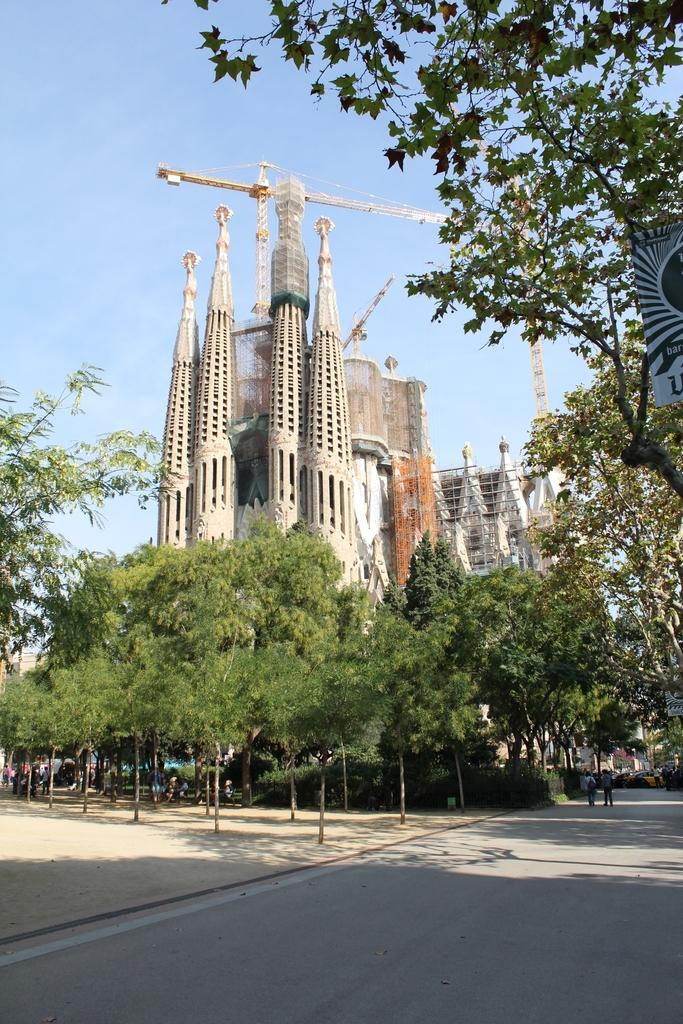What is the main subject of the image? There is a big building under construction in the image. What machinery can be seen at the construction site? A huge crane is present at the construction site. What natural elements are visible around the building? There are a lot of trees around the building. What color is the thumb of the person operating the crane in the image? There is no person operating the crane visible in the image, and therefore no thumb can be seen. 